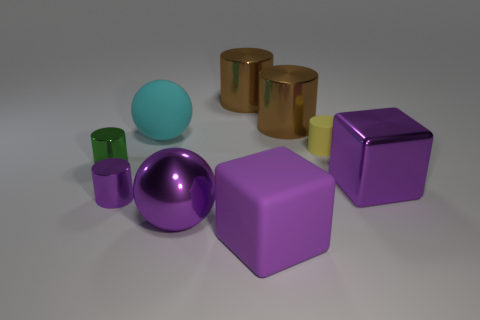Subtract all yellow cylinders. How many cylinders are left? 4 Subtract all cubes. How many objects are left? 7 Add 3 purple shiny spheres. How many purple shiny spheres exist? 4 Subtract 0 red cylinders. How many objects are left? 9 Subtract all small green metal things. Subtract all big rubber spheres. How many objects are left? 7 Add 5 big cyan balls. How many big cyan balls are left? 6 